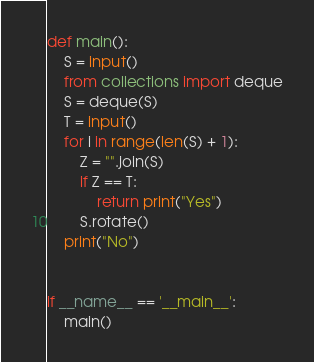<code> <loc_0><loc_0><loc_500><loc_500><_Python_>def main():
    S = input()
    from collections import deque
    S = deque(S)
    T = input()
    for i in range(len(S) + 1):
        Z = "".join(S)
        if Z == T:
            return print("Yes")
        S.rotate()
    print("No")


if __name__ == '__main__':
    main()
</code> 